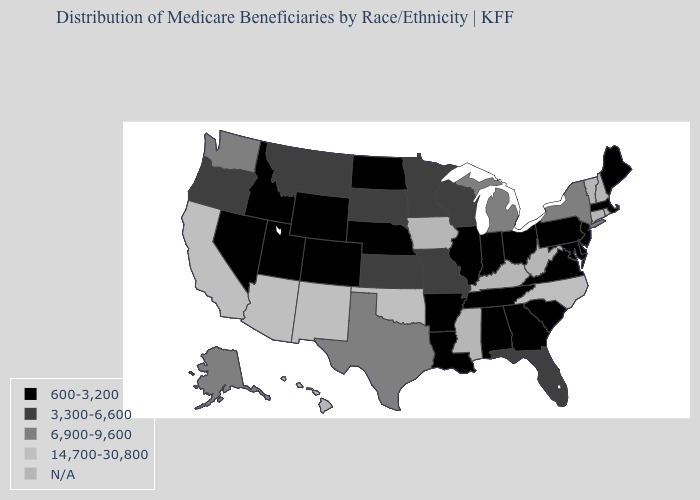Which states hav the highest value in the Northeast?
Concise answer only. New York. What is the highest value in the Northeast ?
Write a very short answer. 6,900-9,600. What is the value of Florida?
Write a very short answer. 3,300-6,600. What is the value of Wisconsin?
Keep it brief. 3,300-6,600. Does the first symbol in the legend represent the smallest category?
Be succinct. Yes. What is the lowest value in the South?
Concise answer only. 600-3,200. What is the value of Virginia?
Quick response, please. 600-3,200. Does the map have missing data?
Give a very brief answer. Yes. Name the states that have a value in the range 14,700-30,800?
Quick response, please. Arizona, California, New Mexico, North Carolina, Oklahoma. Name the states that have a value in the range 14,700-30,800?
Keep it brief. Arizona, California, New Mexico, North Carolina, Oklahoma. What is the lowest value in states that border Wisconsin?
Concise answer only. 600-3,200. Which states have the lowest value in the USA?
Write a very short answer. Alabama, Arkansas, Colorado, Delaware, Georgia, Idaho, Illinois, Indiana, Louisiana, Maine, Maryland, Massachusetts, Nebraska, Nevada, New Jersey, North Dakota, Ohio, Pennsylvania, South Carolina, Tennessee, Utah, Virginia, Wyoming. Does the first symbol in the legend represent the smallest category?
Give a very brief answer. Yes. 